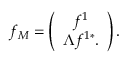Convert formula to latex. <formula><loc_0><loc_0><loc_500><loc_500>f _ { M } = \left ( \begin{array} { c } { { f ^ { 1 } } } \\ { { \Lambda f ^ { 1 * } . } } \end{array} \right ) .</formula> 